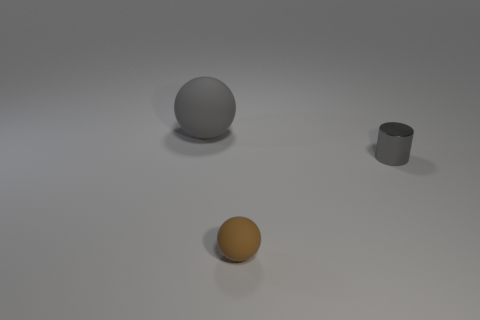What is the color of the tiny object that is the same shape as the big gray matte object?
Offer a terse response. Brown. How many things are tiny red objects or tiny brown rubber things?
Offer a very short reply. 1. There is a rubber object that is in front of the matte sphere behind the gray thing on the right side of the gray matte sphere; what shape is it?
Provide a succinct answer. Sphere. Does the sphere that is in front of the big ball have the same material as the gray object behind the tiny gray metal cylinder?
Keep it short and to the point. Yes. What is the material of the tiny brown thing that is the same shape as the large rubber thing?
Provide a short and direct response. Rubber. Is there any other thing that has the same size as the brown ball?
Offer a very short reply. Yes. There is a gray thing behind the metallic cylinder; is its shape the same as the object that is on the right side of the brown thing?
Make the answer very short. No. Is the number of tiny gray shiny cylinders that are behind the metallic object less than the number of big matte balls in front of the brown matte sphere?
Provide a succinct answer. No. What number of other objects are there of the same shape as the shiny object?
Your response must be concise. 0. What shape is the other thing that is the same material as the small brown thing?
Your answer should be very brief. Sphere. 